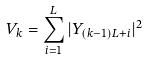Convert formula to latex. <formula><loc_0><loc_0><loc_500><loc_500>V _ { k } = \sum _ { i = 1 } ^ { L } | Y _ { ( k - 1 ) L + i } | ^ { 2 }</formula> 